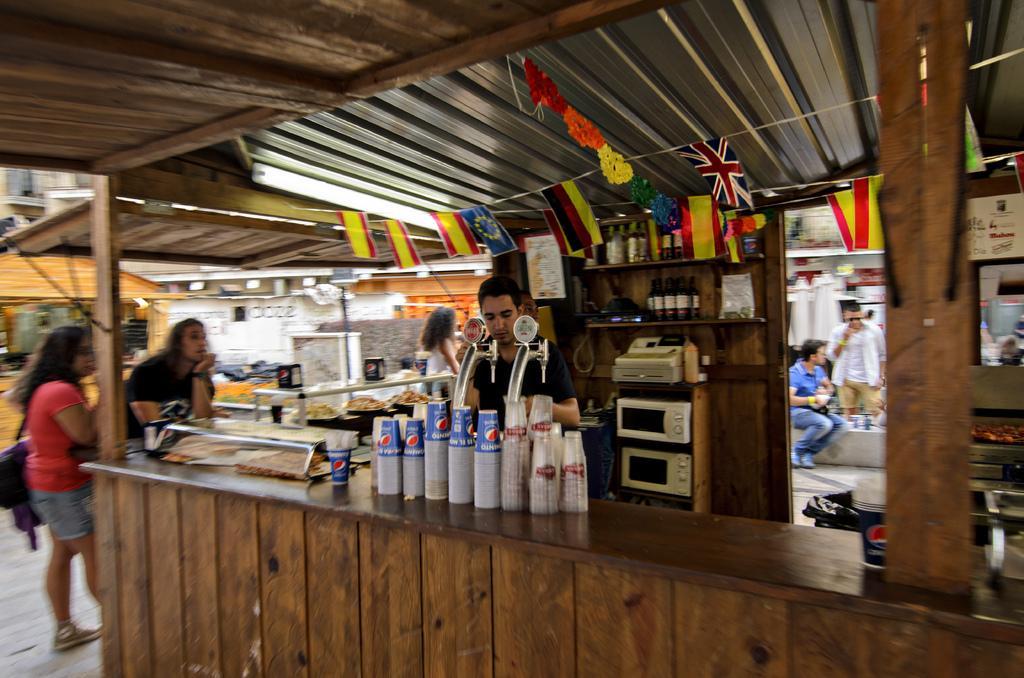How would you summarize this image in a sentence or two? In this image we can see a group of people. We can also see a man standing under a roof beside a wooden table containing some glasses and the machines on it. We can also see the flags and ribbons tied with the thread. On the backside we can see some buildings and the sign boards. 